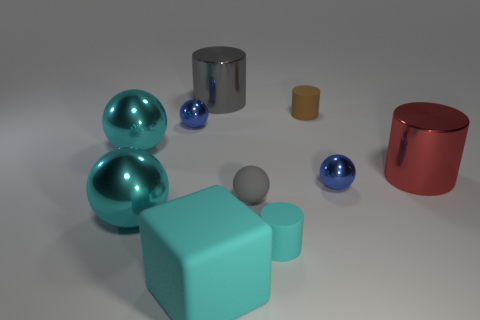Subtract 1 blocks. How many blocks are left? 0 Subtract all big red shiny cylinders. How many cylinders are left? 3 Subtract all blue spheres. How many spheres are left? 3 Subtract all cylinders. How many objects are left? 6 Subtract all yellow spheres. Subtract all gray cylinders. How many spheres are left? 5 Subtract all purple blocks. How many red cylinders are left? 1 Subtract all cyan objects. Subtract all small metallic balls. How many objects are left? 4 Add 9 gray cylinders. How many gray cylinders are left? 10 Add 8 cyan spheres. How many cyan spheres exist? 10 Subtract 0 red blocks. How many objects are left? 10 